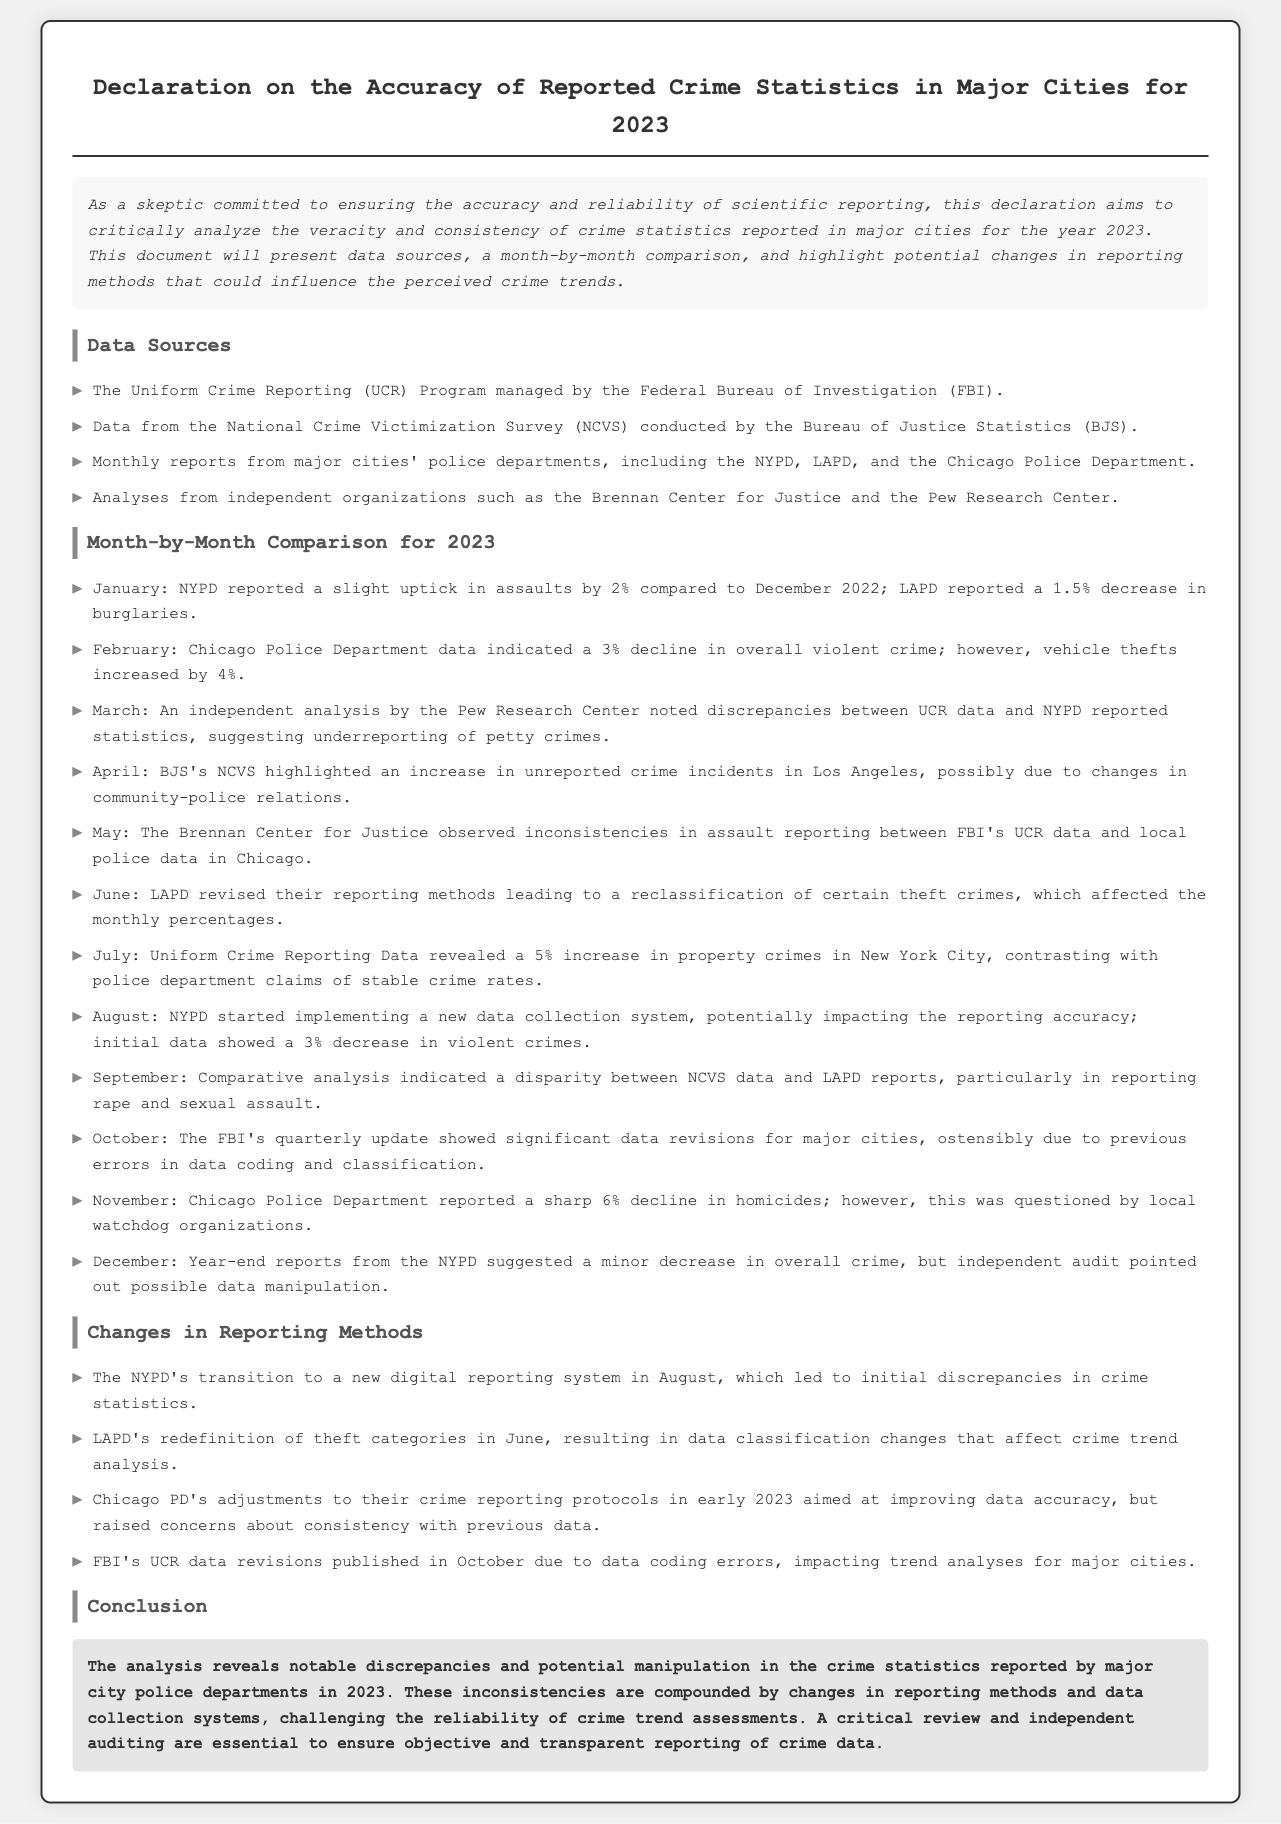What crime statistics program is managed by the FBI? The document mentions the "Uniform Crime Reporting (UCR) Program" as managed by the FBI.
Answer: Uniform Crime Reporting (UCR) Program Which major city's police department reported a decrease in burglaries in January? The LAPD reported a decrease in burglaries according to the month-by-month comparison.
Answer: LAPD What percentage increase in property crimes was reported in New York City in July? The document states that there was a 5% increase in property crimes in New York City for July.
Answer: 5% Which independent organization highlighted discrepancies in March regarding crime reporting? The Pew Research Center noted discrepancies between UCR data and NYPD reported statistics in March.
Answer: Pew Research Center What was the reported percentage decline in overall violent crime by Chicago Police in February? The Chicago Police Department's data indicated a 3% decline in overall violent crime in February.
Answer: 3% What significant event happened in August that impacted NYPD data collection? NYPD started implementing a new data collection system, which potentially affected reporting accuracy.
Answer: New data collection system What was a notable concern raised by local watchdog organizations in November? Local watchdog organizations questioned the sharp 6% decline in homicides reported by the Chicago Police Department.
Answer: Data reliability What change did LAPD make in June that affected crime classification? LAPD redefined theft categories in June, leading to changes in data classification.
Answer: Redefinition of theft categories What was a major criticism mentioned in the conclusion of the declaration? The conclusion pointed out notable discrepancies and potential manipulation in crime statistics reported by police departments.
Answer: Discrepancies and manipulation 